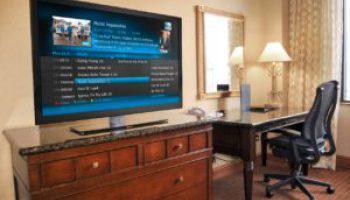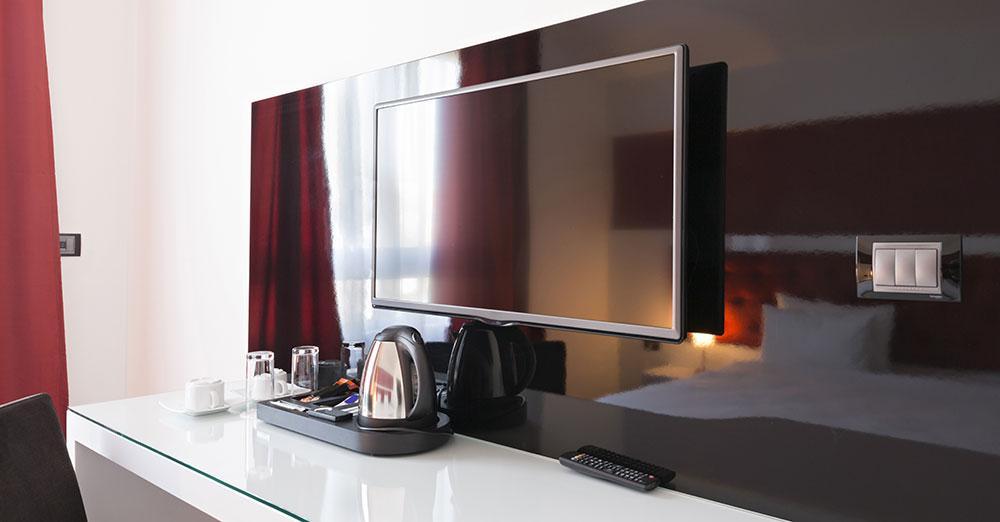The first image is the image on the left, the second image is the image on the right. Assess this claim about the two images: "There is a yellowish lamp turned on near a wall.". Correct or not? Answer yes or no. Yes. 